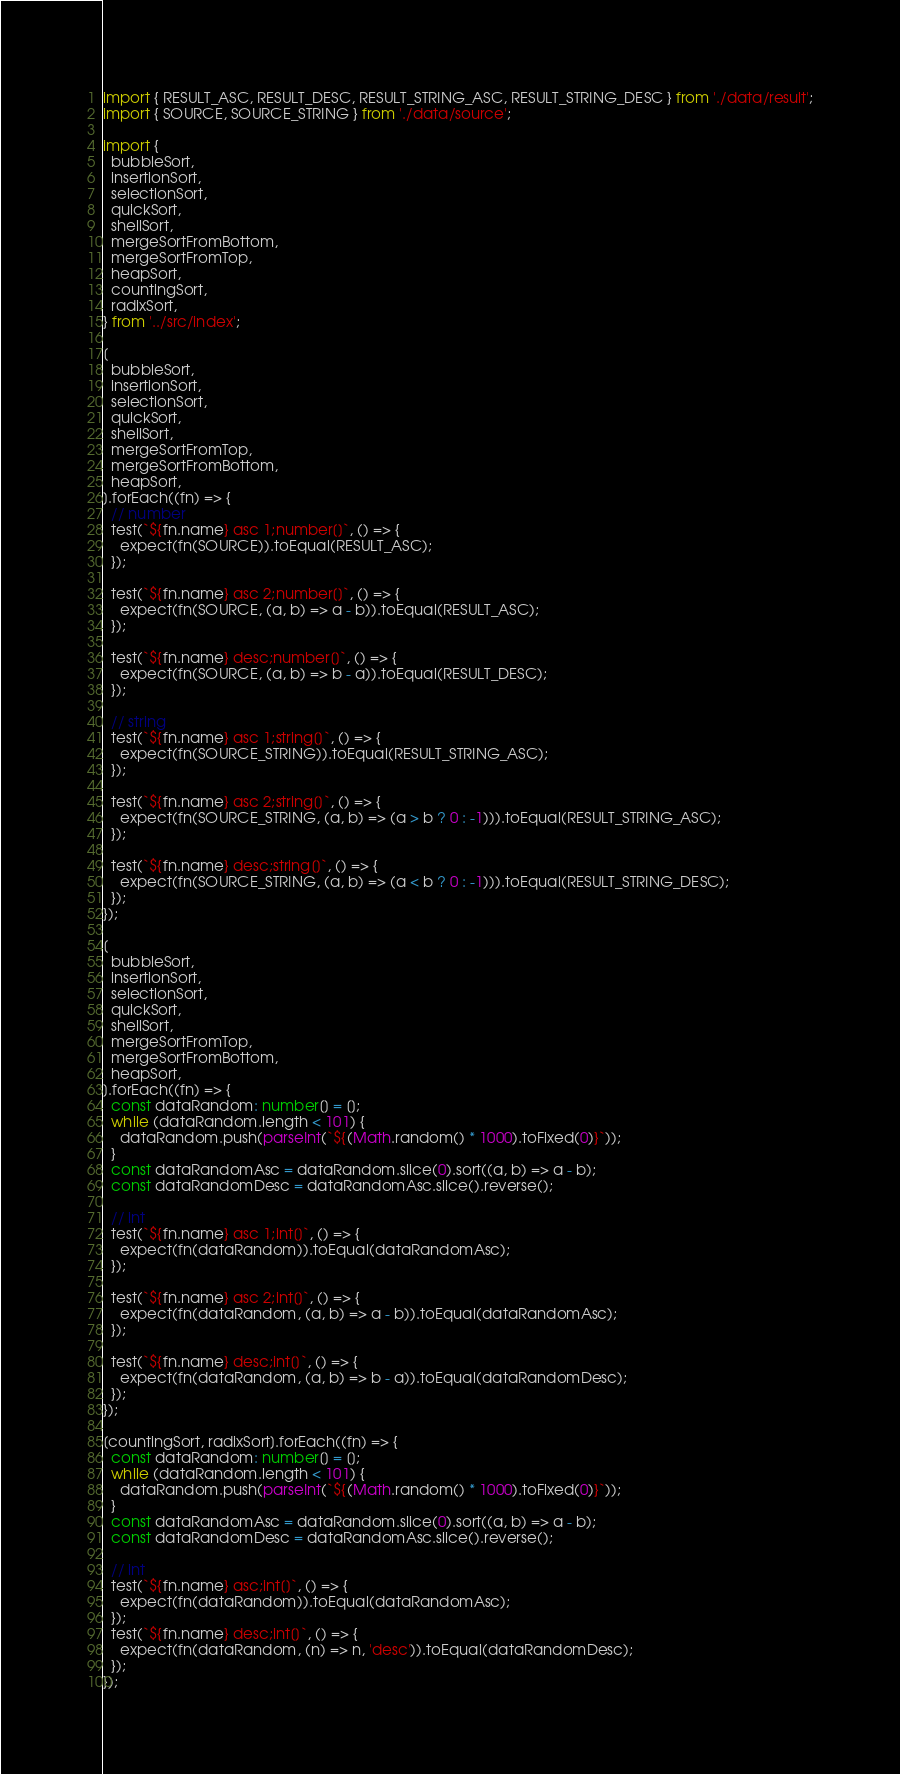Convert code to text. <code><loc_0><loc_0><loc_500><loc_500><_TypeScript_>import { RESULT_ASC, RESULT_DESC, RESULT_STRING_ASC, RESULT_STRING_DESC } from './data/result';
import { SOURCE, SOURCE_STRING } from './data/source';

import {
  bubbleSort,
  insertionSort,
  selectionSort,
  quickSort,
  shellSort,
  mergeSortFromBottom,
  mergeSortFromTop,
  heapSort,
  countingSort,
  radixSort,
} from '../src/index';

[
  bubbleSort,
  insertionSort,
  selectionSort,
  quickSort,
  shellSort,
  mergeSortFromTop,
  mergeSortFromBottom,
  heapSort,
].forEach((fn) => {
  // number
  test(`${fn.name} asc 1;number[]`, () => {
    expect(fn(SOURCE)).toEqual(RESULT_ASC);
  });

  test(`${fn.name} asc 2;number[]`, () => {
    expect(fn(SOURCE, (a, b) => a - b)).toEqual(RESULT_ASC);
  });

  test(`${fn.name} desc;number[]`, () => {
    expect(fn(SOURCE, (a, b) => b - a)).toEqual(RESULT_DESC);
  });

  // string
  test(`${fn.name} asc 1;string[]`, () => {
    expect(fn(SOURCE_STRING)).toEqual(RESULT_STRING_ASC);
  });

  test(`${fn.name} asc 2;string[]`, () => {
    expect(fn(SOURCE_STRING, (a, b) => (a > b ? 0 : -1))).toEqual(RESULT_STRING_ASC);
  });

  test(`${fn.name} desc;string[]`, () => {
    expect(fn(SOURCE_STRING, (a, b) => (a < b ? 0 : -1))).toEqual(RESULT_STRING_DESC);
  });
});

[
  bubbleSort,
  insertionSort,
  selectionSort,
  quickSort,
  shellSort,
  mergeSortFromTop,
  mergeSortFromBottom,
  heapSort,
].forEach((fn) => {
  const dataRandom: number[] = [];
  while (dataRandom.length < 101) {
    dataRandom.push(parseInt(`${(Math.random() * 1000).toFixed(0)}`));
  }
  const dataRandomAsc = dataRandom.slice(0).sort((a, b) => a - b);
  const dataRandomDesc = dataRandomAsc.slice().reverse();

  // int
  test(`${fn.name} asc 1;int[]`, () => {
    expect(fn(dataRandom)).toEqual(dataRandomAsc);
  });

  test(`${fn.name} asc 2;int[]`, () => {
    expect(fn(dataRandom, (a, b) => a - b)).toEqual(dataRandomAsc);
  });

  test(`${fn.name} desc;int[]`, () => {
    expect(fn(dataRandom, (a, b) => b - a)).toEqual(dataRandomDesc);
  });
});

[countingSort, radixSort].forEach((fn) => {
  const dataRandom: number[] = [];
  while (dataRandom.length < 101) {
    dataRandom.push(parseInt(`${(Math.random() * 1000).toFixed(0)}`));
  }
  const dataRandomAsc = dataRandom.slice(0).sort((a, b) => a - b);
  const dataRandomDesc = dataRandomAsc.slice().reverse();

  // int
  test(`${fn.name} asc;int[]`, () => {
    expect(fn(dataRandom)).toEqual(dataRandomAsc);
  });
  test(`${fn.name} desc;int[]`, () => {
    expect(fn(dataRandom, (n) => n, 'desc')).toEqual(dataRandomDesc);
  });
});
</code> 